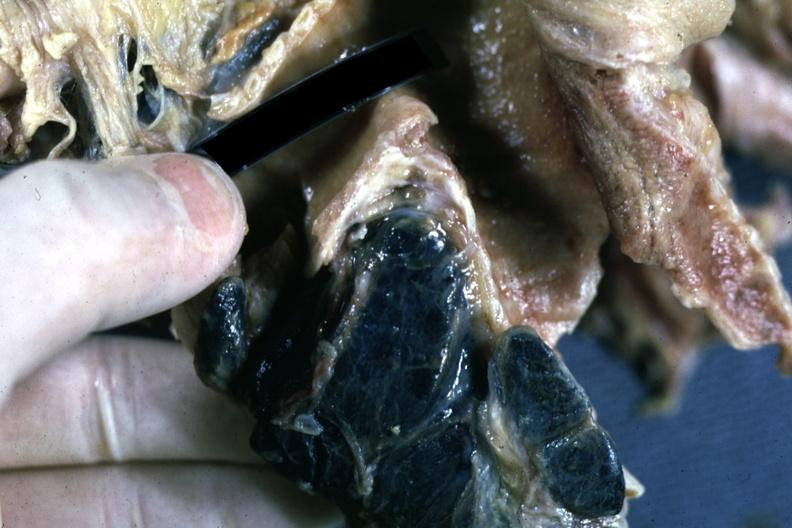s intraductal papillomatosis sectioned carinal nodes shown close-up nodes are filled with black pigment?
Answer the question using a single word or phrase. No 